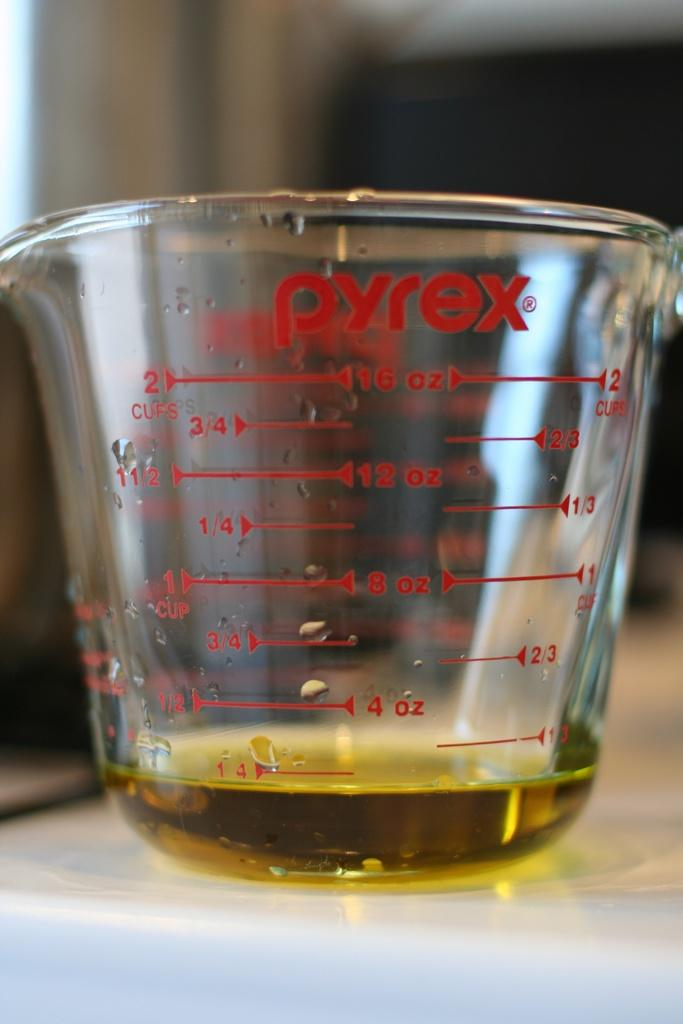<image>
Provide a brief description of the given image. a Pyrex cup that has many numbers on it 